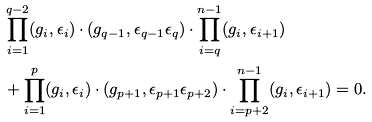<formula> <loc_0><loc_0><loc_500><loc_500>& \prod _ { i = 1 } ^ { q - 2 } ( g _ { i } , \epsilon _ { i } ) \cdot ( g _ { q - 1 } , \epsilon _ { q - 1 } \epsilon _ { q } ) \cdot \prod _ { i = q } ^ { n - 1 } ( g _ { i } , \epsilon _ { i + 1 } ) \\ & + \prod _ { i = 1 } ^ { p } ( g _ { i } , \epsilon _ { i } ) \cdot ( g _ { p + 1 } , \epsilon _ { p + 1 } \epsilon _ { p + 2 } ) \cdot \prod _ { i = p + 2 } ^ { n - 1 } ( g _ { i } , \epsilon _ { i + 1 } ) = 0 .</formula> 